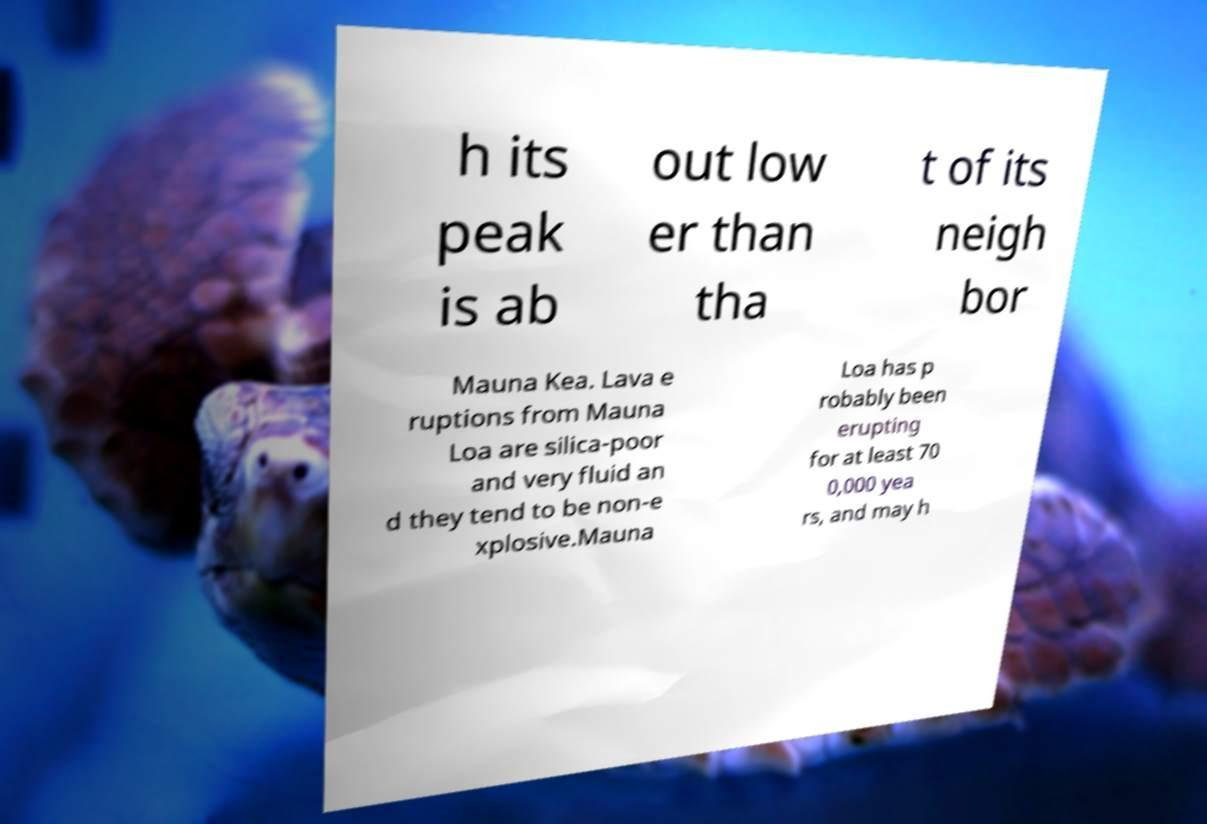Could you assist in decoding the text presented in this image and type it out clearly? h its peak is ab out low er than tha t of its neigh bor Mauna Kea. Lava e ruptions from Mauna Loa are silica-poor and very fluid an d they tend to be non-e xplosive.Mauna Loa has p robably been erupting for at least 70 0,000 yea rs, and may h 